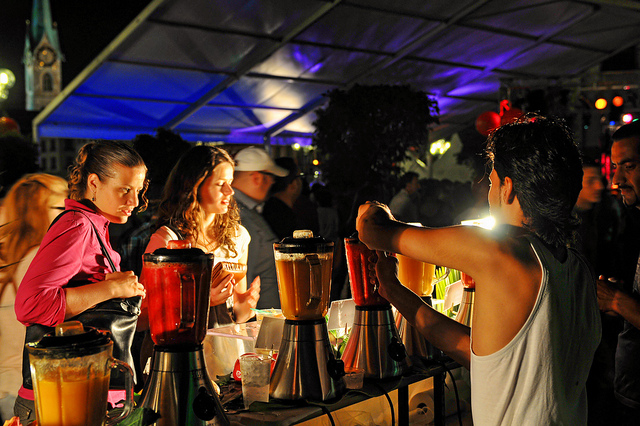<image>What kind of demonstration is happening here? It is ambiguous what kind of demonstration is happening here. It can be a party, blender demonstration, smoothies making, mixing drinks, bartending, juicing, or drink making. What kind of demonstration is happening here? I'm not sure what kind of demonstration is happening here. It could be a party, blender, smoothies, mixing drinks, bartending, juicing, or drink making. 